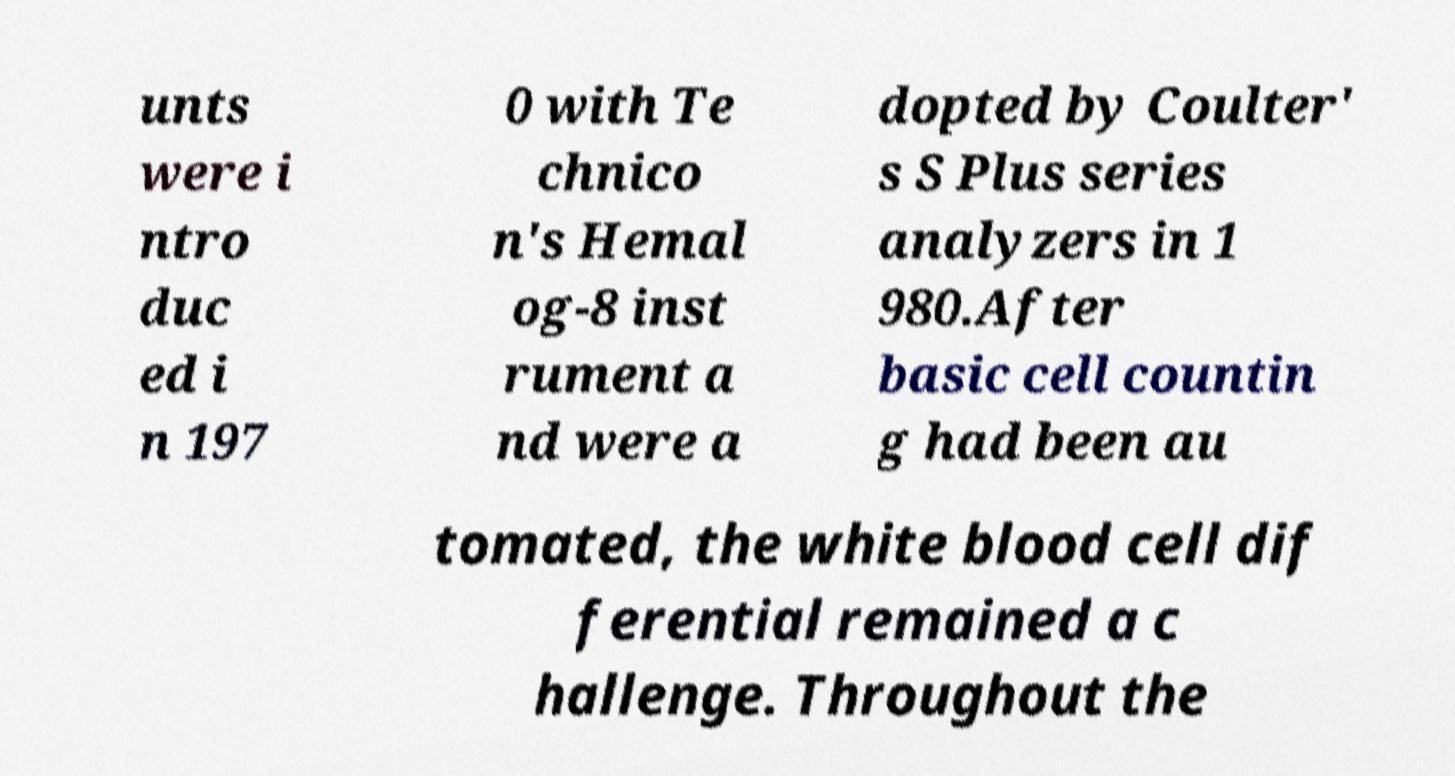Please read and relay the text visible in this image. What does it say? unts were i ntro duc ed i n 197 0 with Te chnico n's Hemal og-8 inst rument a nd were a dopted by Coulter' s S Plus series analyzers in 1 980.After basic cell countin g had been au tomated, the white blood cell dif ferential remained a c hallenge. Throughout the 